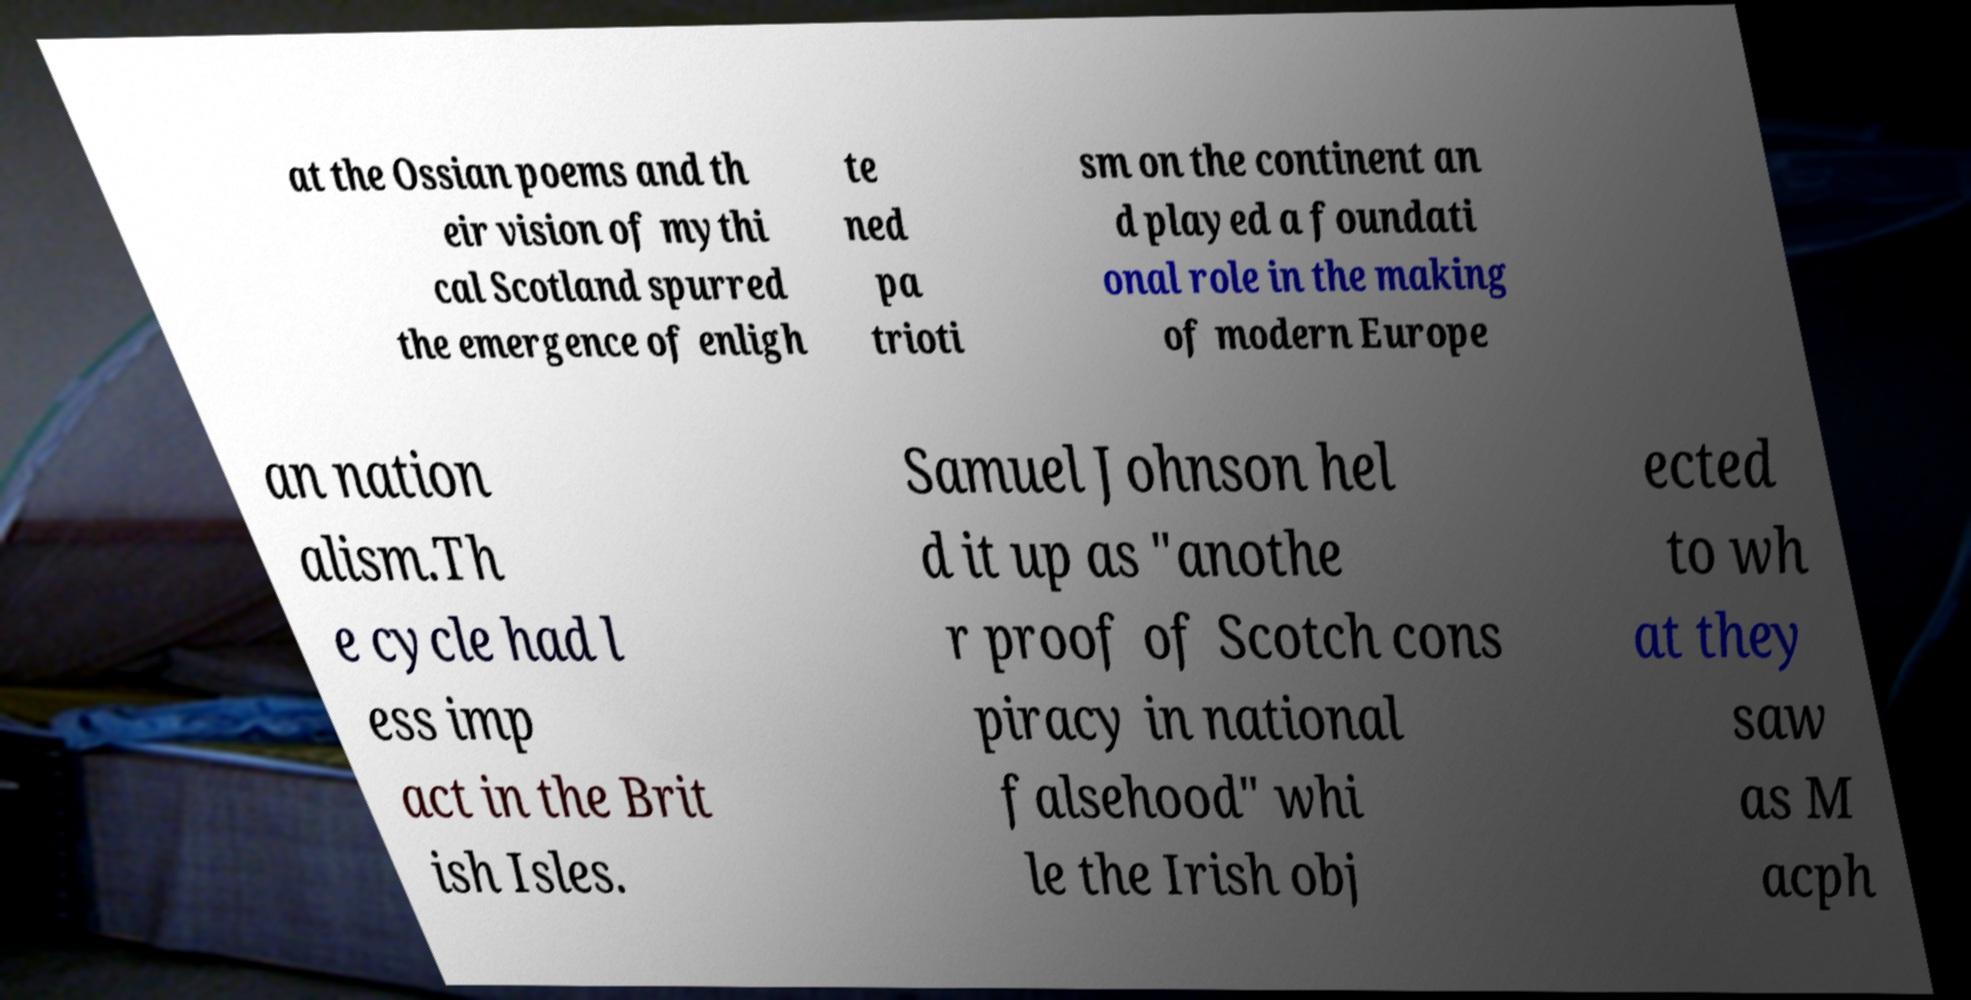Can you accurately transcribe the text from the provided image for me? at the Ossian poems and th eir vision of mythi cal Scotland spurred the emergence of enligh te ned pa trioti sm on the continent an d played a foundati onal role in the making of modern Europe an nation alism.Th e cycle had l ess imp act in the Brit ish Isles. Samuel Johnson hel d it up as "anothe r proof of Scotch cons piracy in national falsehood" whi le the Irish obj ected to wh at they saw as M acph 